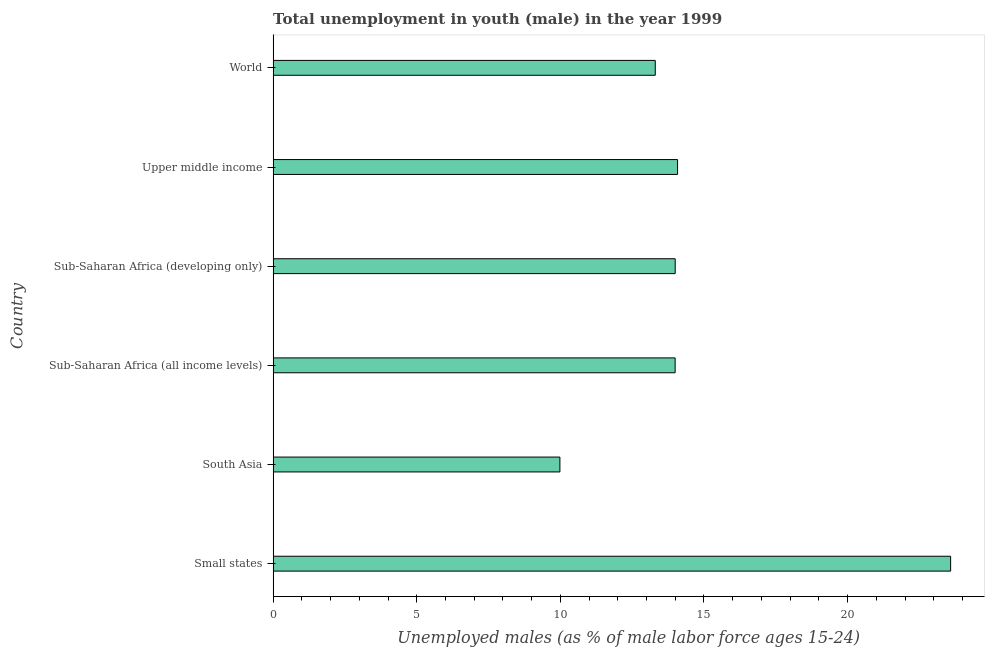Does the graph contain any zero values?
Your answer should be very brief. No. What is the title of the graph?
Give a very brief answer. Total unemployment in youth (male) in the year 1999. What is the label or title of the X-axis?
Offer a terse response. Unemployed males (as % of male labor force ages 15-24). What is the label or title of the Y-axis?
Offer a terse response. Country. What is the unemployed male youth population in South Asia?
Make the answer very short. 9.98. Across all countries, what is the maximum unemployed male youth population?
Keep it short and to the point. 23.59. Across all countries, what is the minimum unemployed male youth population?
Provide a short and direct response. 9.98. In which country was the unemployed male youth population maximum?
Your answer should be compact. Small states. What is the sum of the unemployed male youth population?
Offer a terse response. 88.95. What is the difference between the unemployed male youth population in Sub-Saharan Africa (all income levels) and Upper middle income?
Make the answer very short. -0.09. What is the average unemployed male youth population per country?
Your answer should be very brief. 14.82. What is the median unemployed male youth population?
Keep it short and to the point. 14. In how many countries, is the unemployed male youth population greater than 4 %?
Keep it short and to the point. 6. What is the ratio of the unemployed male youth population in South Asia to that in Sub-Saharan Africa (all income levels)?
Make the answer very short. 0.71. Is the unemployed male youth population in Sub-Saharan Africa (all income levels) less than that in Sub-Saharan Africa (developing only)?
Ensure brevity in your answer.  Yes. Is the difference between the unemployed male youth population in Small states and Sub-Saharan Africa (all income levels) greater than the difference between any two countries?
Keep it short and to the point. No. What is the difference between the highest and the second highest unemployed male youth population?
Provide a succinct answer. 9.51. What is the difference between the highest and the lowest unemployed male youth population?
Give a very brief answer. 13.6. In how many countries, is the unemployed male youth population greater than the average unemployed male youth population taken over all countries?
Your response must be concise. 1. How many bars are there?
Your response must be concise. 6. Are all the bars in the graph horizontal?
Offer a very short reply. Yes. How many countries are there in the graph?
Provide a succinct answer. 6. What is the difference between two consecutive major ticks on the X-axis?
Keep it short and to the point. 5. Are the values on the major ticks of X-axis written in scientific E-notation?
Your answer should be very brief. No. What is the Unemployed males (as % of male labor force ages 15-24) of Small states?
Your response must be concise. 23.59. What is the Unemployed males (as % of male labor force ages 15-24) of South Asia?
Offer a very short reply. 9.98. What is the Unemployed males (as % of male labor force ages 15-24) of Sub-Saharan Africa (all income levels)?
Offer a very short reply. 14. What is the Unemployed males (as % of male labor force ages 15-24) in Sub-Saharan Africa (developing only)?
Offer a very short reply. 14. What is the Unemployed males (as % of male labor force ages 15-24) in Upper middle income?
Your response must be concise. 14.08. What is the Unemployed males (as % of male labor force ages 15-24) of World?
Your answer should be compact. 13.3. What is the difference between the Unemployed males (as % of male labor force ages 15-24) in Small states and South Asia?
Provide a succinct answer. 13.6. What is the difference between the Unemployed males (as % of male labor force ages 15-24) in Small states and Sub-Saharan Africa (all income levels)?
Offer a very short reply. 9.59. What is the difference between the Unemployed males (as % of male labor force ages 15-24) in Small states and Sub-Saharan Africa (developing only)?
Keep it short and to the point. 9.59. What is the difference between the Unemployed males (as % of male labor force ages 15-24) in Small states and Upper middle income?
Ensure brevity in your answer.  9.51. What is the difference between the Unemployed males (as % of male labor force ages 15-24) in Small states and World?
Your answer should be compact. 10.28. What is the difference between the Unemployed males (as % of male labor force ages 15-24) in South Asia and Sub-Saharan Africa (all income levels)?
Give a very brief answer. -4.01. What is the difference between the Unemployed males (as % of male labor force ages 15-24) in South Asia and Sub-Saharan Africa (developing only)?
Give a very brief answer. -4.01. What is the difference between the Unemployed males (as % of male labor force ages 15-24) in South Asia and Upper middle income?
Provide a short and direct response. -4.1. What is the difference between the Unemployed males (as % of male labor force ages 15-24) in South Asia and World?
Your answer should be very brief. -3.32. What is the difference between the Unemployed males (as % of male labor force ages 15-24) in Sub-Saharan Africa (all income levels) and Sub-Saharan Africa (developing only)?
Your answer should be very brief. -0. What is the difference between the Unemployed males (as % of male labor force ages 15-24) in Sub-Saharan Africa (all income levels) and Upper middle income?
Provide a succinct answer. -0.08. What is the difference between the Unemployed males (as % of male labor force ages 15-24) in Sub-Saharan Africa (all income levels) and World?
Make the answer very short. 0.69. What is the difference between the Unemployed males (as % of male labor force ages 15-24) in Sub-Saharan Africa (developing only) and Upper middle income?
Provide a succinct answer. -0.08. What is the difference between the Unemployed males (as % of male labor force ages 15-24) in Sub-Saharan Africa (developing only) and World?
Keep it short and to the point. 0.69. What is the difference between the Unemployed males (as % of male labor force ages 15-24) in Upper middle income and World?
Offer a very short reply. 0.78. What is the ratio of the Unemployed males (as % of male labor force ages 15-24) in Small states to that in South Asia?
Provide a short and direct response. 2.36. What is the ratio of the Unemployed males (as % of male labor force ages 15-24) in Small states to that in Sub-Saharan Africa (all income levels)?
Give a very brief answer. 1.69. What is the ratio of the Unemployed males (as % of male labor force ages 15-24) in Small states to that in Sub-Saharan Africa (developing only)?
Your answer should be compact. 1.69. What is the ratio of the Unemployed males (as % of male labor force ages 15-24) in Small states to that in Upper middle income?
Ensure brevity in your answer.  1.68. What is the ratio of the Unemployed males (as % of male labor force ages 15-24) in Small states to that in World?
Ensure brevity in your answer.  1.77. What is the ratio of the Unemployed males (as % of male labor force ages 15-24) in South Asia to that in Sub-Saharan Africa (all income levels)?
Offer a terse response. 0.71. What is the ratio of the Unemployed males (as % of male labor force ages 15-24) in South Asia to that in Sub-Saharan Africa (developing only)?
Provide a succinct answer. 0.71. What is the ratio of the Unemployed males (as % of male labor force ages 15-24) in South Asia to that in Upper middle income?
Provide a succinct answer. 0.71. What is the ratio of the Unemployed males (as % of male labor force ages 15-24) in Sub-Saharan Africa (all income levels) to that in Sub-Saharan Africa (developing only)?
Offer a terse response. 1. What is the ratio of the Unemployed males (as % of male labor force ages 15-24) in Sub-Saharan Africa (all income levels) to that in World?
Your answer should be compact. 1.05. What is the ratio of the Unemployed males (as % of male labor force ages 15-24) in Sub-Saharan Africa (developing only) to that in World?
Your response must be concise. 1.05. What is the ratio of the Unemployed males (as % of male labor force ages 15-24) in Upper middle income to that in World?
Offer a terse response. 1.06. 